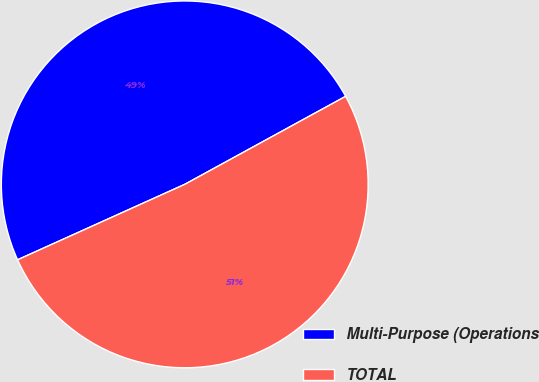<chart> <loc_0><loc_0><loc_500><loc_500><pie_chart><fcel>Multi-Purpose (Operations<fcel>TOTAL<nl><fcel>48.78%<fcel>51.22%<nl></chart> 